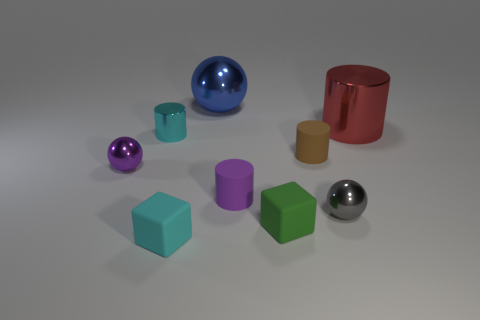Is there any other thing that has the same shape as the gray metallic object?
Offer a terse response. Yes. There is a rubber block to the left of the green object; is it the same color as the shiny cylinder left of the small green rubber cube?
Give a very brief answer. Yes. How many matte things are tiny brown cylinders or tiny gray blocks?
Provide a short and direct response. 1. What is the shape of the thing that is behind the cylinder that is behind the tiny cyan metal cylinder?
Provide a short and direct response. Sphere. Is the cylinder right of the brown matte object made of the same material as the purple thing that is right of the small cyan rubber object?
Make the answer very short. No. How many big red cylinders are in front of the tiny matte cylinder on the right side of the purple matte cylinder?
Ensure brevity in your answer.  0. Do the big metal object in front of the big blue sphere and the tiny purple object right of the blue metallic ball have the same shape?
Make the answer very short. Yes. There is a cylinder that is on the left side of the small green block and behind the brown matte object; what is its size?
Your response must be concise. Small. What is the color of the other matte thing that is the same shape as the green thing?
Make the answer very short. Cyan. The matte cylinder in front of the small rubber cylinder to the right of the small purple matte object is what color?
Offer a terse response. Purple. 